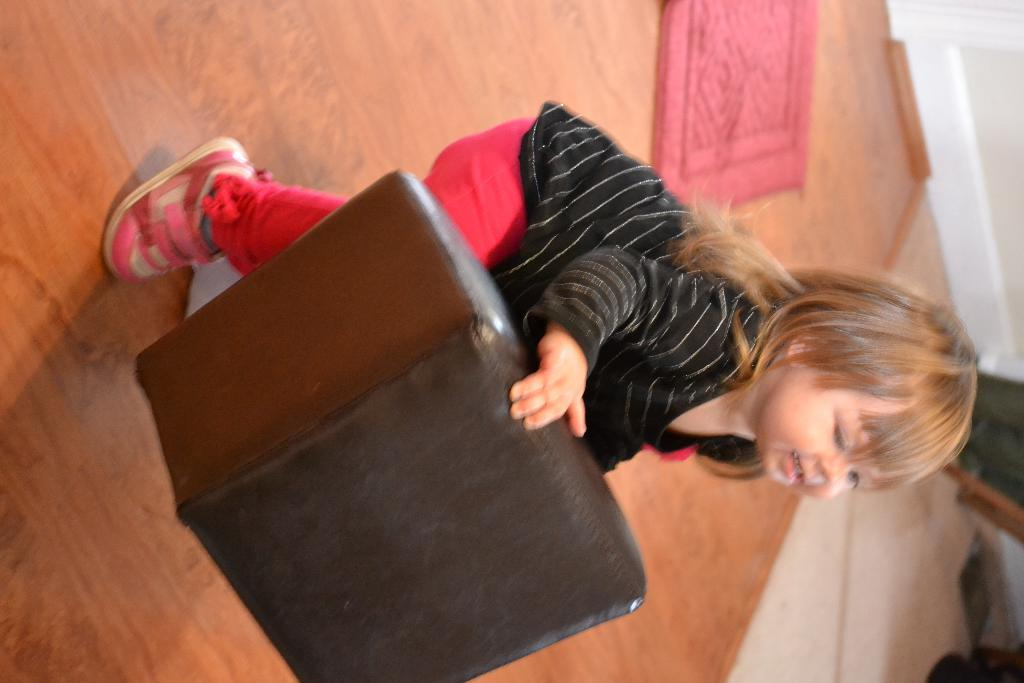Who is the main subject in the image? There is a girl in the image. What is the girl holding in the image? The girl is holding an object. Can you describe the object on the right side of the image? There is an object on the right side of the image, but its description is not provided in the facts. What is on the floor in the image? There is a mat on the floor in the image. How many kittens are sitting on the judge's lap in the image? There are no kittens or judges present in the image. What type of quartz can be seen in the image? There is no quartz present in the image. 